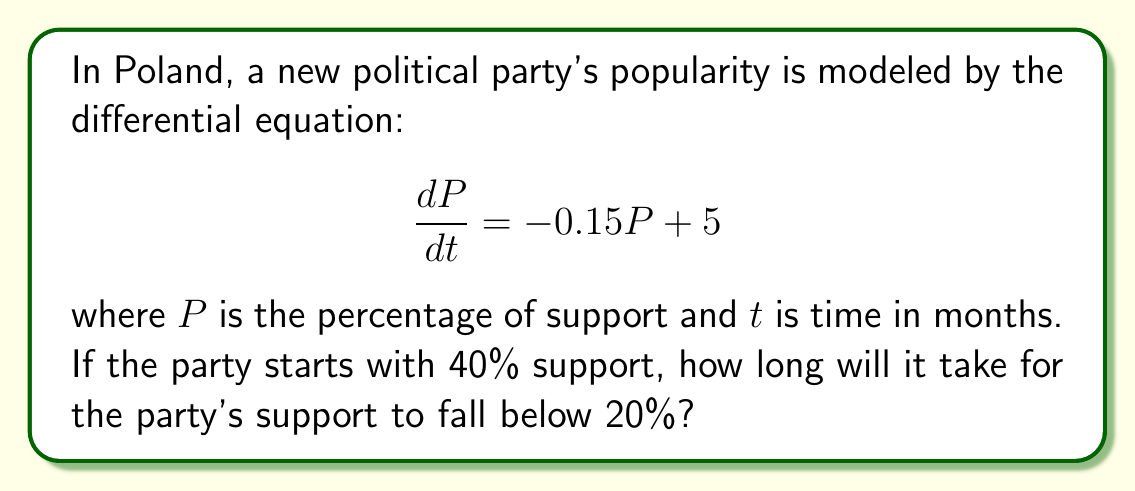Help me with this question. Let's approach this step-by-step:

1) First, we need to solve the differential equation. This is a first-order linear differential equation.

2) The general solution to this equation is:

   $$P(t) = Ce^{-0.15t} + \frac{5}{0.15} = Ce^{-0.15t} + 33.33$$

   where $C$ is a constant we need to determine.

3) We know that at $t=0$, $P(0) = 40$. Let's use this initial condition:

   $$40 = Ce^{-0.15(0)} + 33.33$$
   $$40 = C + 33.33$$
   $$C = 6.67$$

4) So, our particular solution is:

   $$P(t) = 6.67e^{-0.15t} + 33.33$$

5) Now, we need to find when $P(t) = 20$:

   $$20 = 6.67e^{-0.15t} + 33.33$$
   $$-13.33 = 6.67e^{-0.15t}$$
   $$-2 = e^{-0.15t}$$

6) Taking the natural log of both sides:

   $$\ln(-2) = -0.15t$$
   $$t = \frac{\ln(-2)}{-0.15} \approx 4.62$$

7) However, $\ln(-2)$ is undefined in the real number system. This means the party's support will never fall below 20%.

8) We can verify this by noting that as $t \to \infty$, $P(t) \to 33.33\%$.
Answer: The party's support will never fall below 20%. It will asymptotically approach 33.33% as time goes to infinity. 